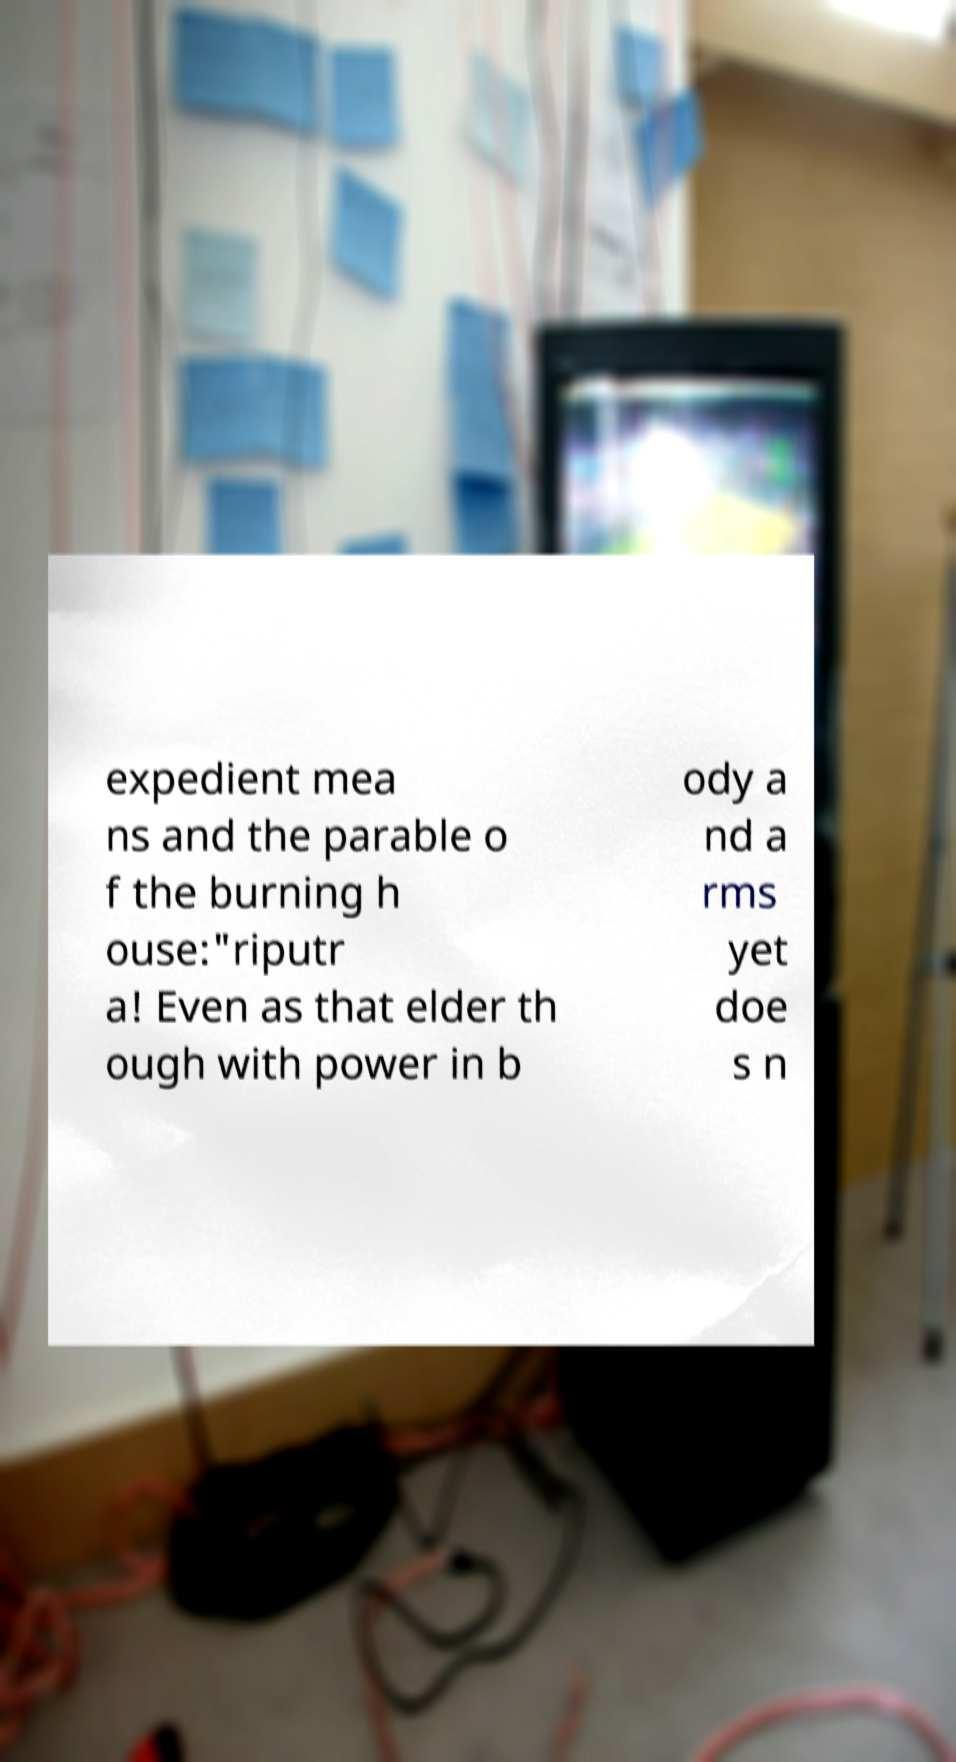Please identify and transcribe the text found in this image. expedient mea ns and the parable o f the burning h ouse:"riputr a! Even as that elder th ough with power in b ody a nd a rms yet doe s n 